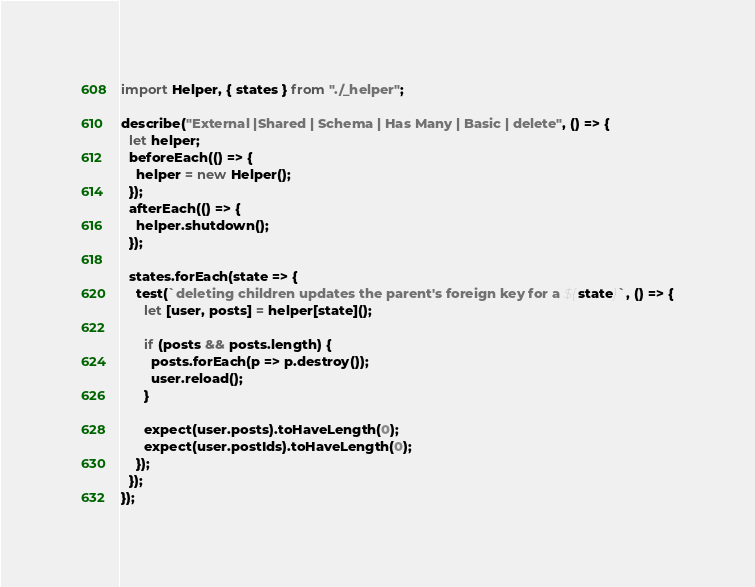<code> <loc_0><loc_0><loc_500><loc_500><_JavaScript_>import Helper, { states } from "./_helper";

describe("External |Shared | Schema | Has Many | Basic | delete", () => {
  let helper;
  beforeEach(() => {
    helper = new Helper();
  });
  afterEach(() => {
    helper.shutdown();
  });

  states.forEach(state => {
    test(`deleting children updates the parent's foreign key for a ${state}`, () => {
      let [user, posts] = helper[state]();

      if (posts && posts.length) {
        posts.forEach(p => p.destroy());
        user.reload();
      }

      expect(user.posts).toHaveLength(0);
      expect(user.postIds).toHaveLength(0);
    });
  });
});
</code> 